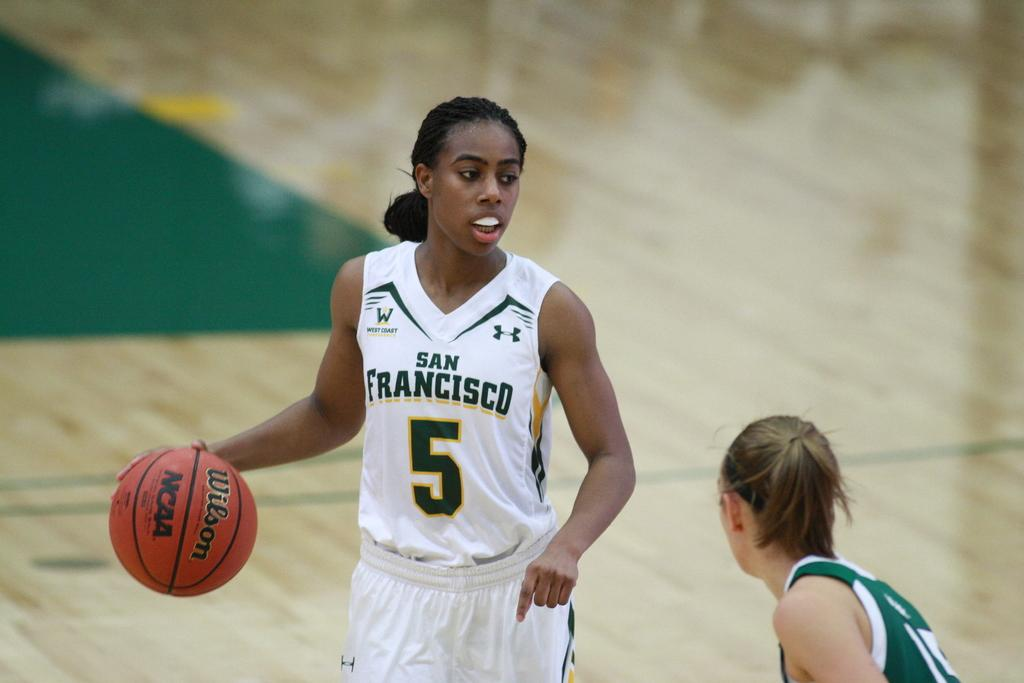Provide a one-sentence caption for the provided image. A female basketball player wears a uniform which reads San Francisco on the front. 